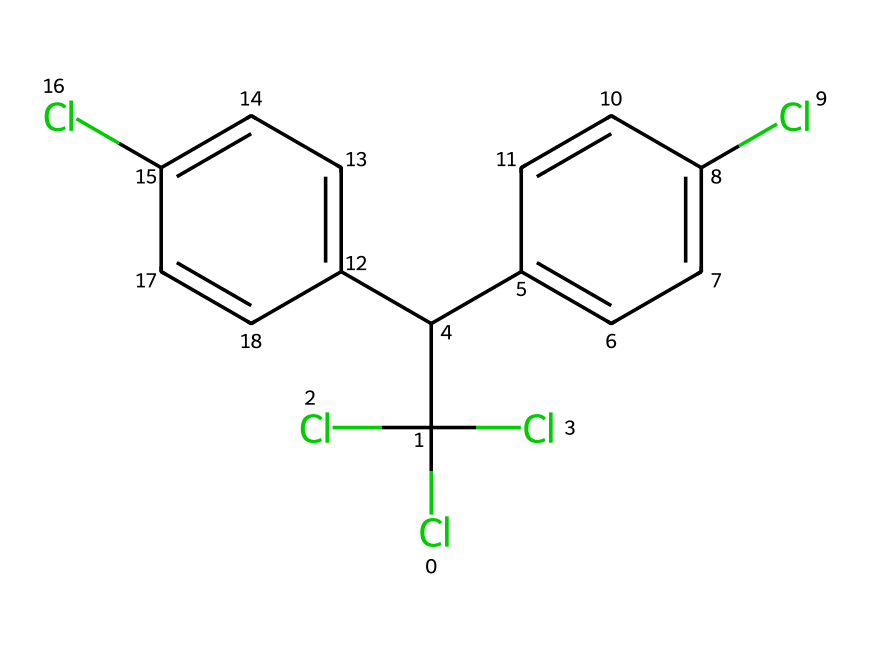What is the molecular formula of DDT? By counting the atoms in the SMILES representation, there are 14 carbon (C), 9 hydrogen (H), and 4 chlorine (Cl) atoms. Thus, the molecular formula can be constructed as C14H9Cl4.
Answer: C14H9Cl4 How many chlorine atoms are present in DDT? From the SMILES, we can see that there are 4 chlorine (Cl) atoms indicated by the presence of "Cl" four times.
Answer: 4 What type of chemical is DDT categorized as? DDT is a pesticide and can also be categorized under organochlorines due to its composition, which features multiple chlorine atoms bonded with carbon structures.
Answer: organochlorine How many aromatic rings are in the structure of DDT? In the SMILES representation, there are two instances of "c," indicating distinct aromatic rings, which are found in the biphenyl structure of DDT.
Answer: 2 What is the primary functional group in DDT that contributes to its bioactivity? The presence of chlorine atoms significantly influences DDT's bioactivity by enhancing its lipophilicity, thus acting as a chlorinated hydrocarbon.
Answer: chlorinated hydrocarbon What can we infer about the stability of DDT based on its chemical structure? The presence of multiple chlorine atoms and stable aromatic rings suggests a high degree of stability, making DDT resistant to biodegradation.
Answer: high stability 